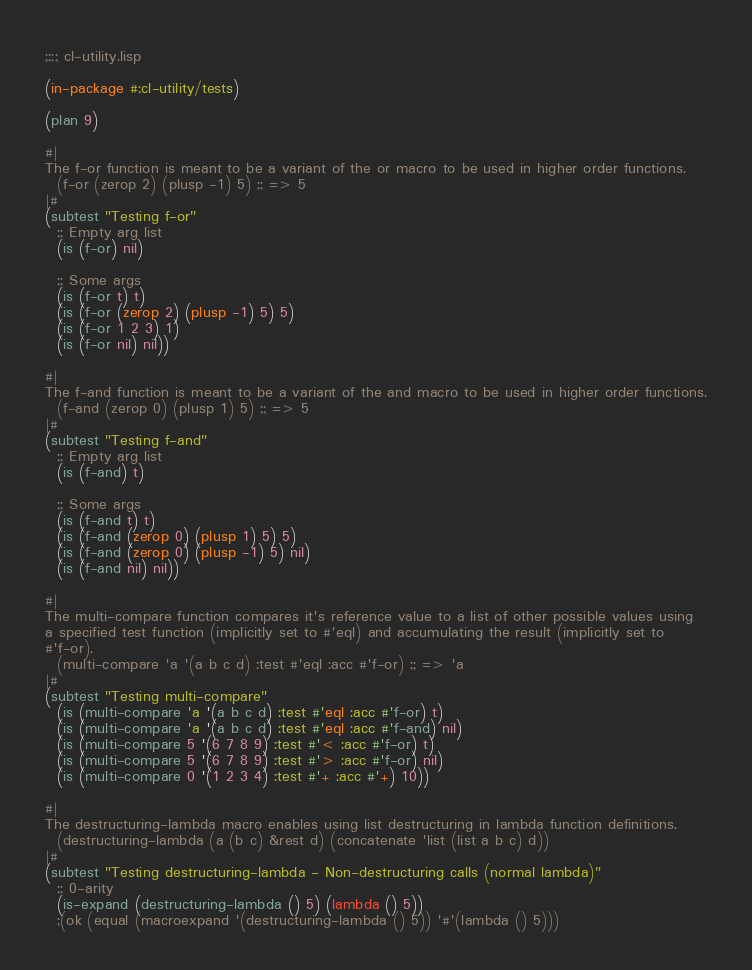<code> <loc_0><loc_0><loc_500><loc_500><_Lisp_>;;;; cl-utility.lisp

(in-package #:cl-utility/tests)

(plan 9)

#|
The f-or function is meant to be a variant of the or macro to be used in higher order functions.
  (f-or (zerop 2) (plusp -1) 5) ;; => 5
|#
(subtest "Testing f-or"
  ;; Empty arg list
  (is (f-or) nil)

  ;; Some args
  (is (f-or t) t)
  (is (f-or (zerop 2) (plusp -1) 5) 5)
  (is (f-or 1 2 3) 1)
  (is (f-or nil) nil))

#|
The f-and function is meant to be a variant of the and macro to be used in higher order functions.
  (f-and (zerop 0) (plusp 1) 5) ;; => 5
|#
(subtest "Testing f-and"
  ;; Empty arg list
  (is (f-and) t)
  
  ;; Some args 
  (is (f-and t) t)
  (is (f-and (zerop 0) (plusp 1) 5) 5)
  (is (f-and (zerop 0) (plusp -1) 5) nil)
  (is (f-and nil) nil))

#|
The multi-compare function compares it's reference value to a list of other possible values using
a specified test function (implicitly set to #'eql) and accumulating the result (implicitly set to
#'f-or).
  (multi-compare 'a '(a b c d) :test #'eql :acc #'f-or) ;; => 'a 
|#
(subtest "Testing multi-compare"
  (is (multi-compare 'a '(a b c d) :test #'eql :acc #'f-or) t)
  (is (multi-compare 'a '(a b c d) :test #'eql :acc #'f-and) nil)
  (is (multi-compare 5 '(6 7 8 9) :test #'< :acc #'f-or) t)
  (is (multi-compare 5 '(6 7 8 9) :test #'> :acc #'f-or) nil)
  (is (multi-compare 0 '(1 2 3 4) :test #'+ :acc #'+) 10))

#|
The destructuring-lambda macro enables using list destructuring in lambda function definitions.
  (destructuring-lambda (a (b c) &rest d) (concatenate 'list (list a b c) d))
|#
(subtest "Testing destructuring-lambda - Non-destructuring calls (normal lambda)"
  ;; 0-arity
  (is-expand (destructuring-lambda () 5) (lambda () 5))
  ;(ok (equal (macroexpand '(destructuring-lambda () 5)) '#'(lambda () 5)))</code> 